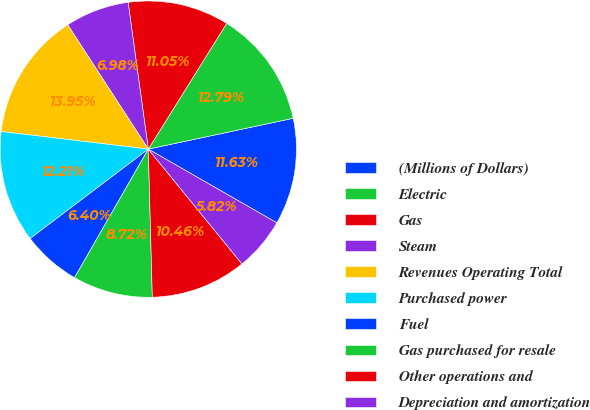<chart> <loc_0><loc_0><loc_500><loc_500><pie_chart><fcel>(Millions of Dollars)<fcel>Electric<fcel>Gas<fcel>Steam<fcel>Revenues Operating Total<fcel>Purchased power<fcel>Fuel<fcel>Gas purchased for resale<fcel>Other operations and<fcel>Depreciation and amortization<nl><fcel>11.63%<fcel>12.79%<fcel>11.05%<fcel>6.98%<fcel>13.95%<fcel>12.21%<fcel>6.4%<fcel>8.72%<fcel>10.46%<fcel>5.82%<nl></chart> 